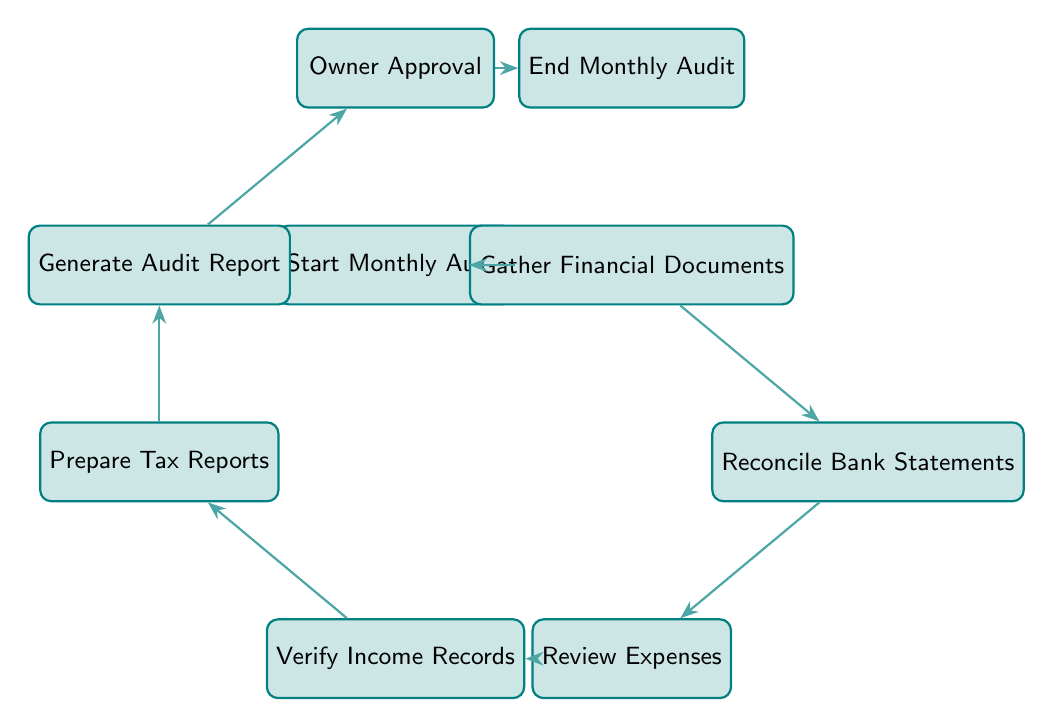What is the first step in the Monthly Audit Workflow? The first step is indicated by the node "Start Monthly Audit." Following the flow of the diagram, this node initiates the process.
Answer: Start Monthly Audit How many nodes are in the Monthly Audit Workflow diagram? By counting the distinct processes and points in the diagram, there are a total of eight nodes listed.
Answer: Eight What comes after "Verify Income Records"? From the diagram, we can see that after the node "Verify Income Records," the next step is "Prepare Tax Reports," following the directed edge.
Answer: Prepare Tax Reports Which node precedes the "Generate Audit Report"? The diagram shows that immediately before "Generate Audit Report," the node "Prepare Tax Reports" is positioned, leading to it.
Answer: Prepare Tax Reports What is the last step in the Monthly Audit Workflow? The final node in the diagram is labeled "End Monthly Audit," which signifies the completion of the workflow process.
Answer: End Monthly Audit Which nodes are connected by an edge leading to the "Owner Approval"? According to the diagram, the nodes connected to "Owner Approval" are "Generate Audit Report," which leads directly to it via an edge.
Answer: Generate Audit Report What is the relationship between "Reconcile Bank Statements" and "Review Expenses"? In the diagram, "Reconcile Bank Statements" is directly connected to "Review Expenses," indicating a sequential flow from one task to the next.
Answer: Directly connected How many edges are present in the diagram? By counting the directed connections between nodes, there are a total of seven edges that signify the workflow steps.
Answer: Seven 